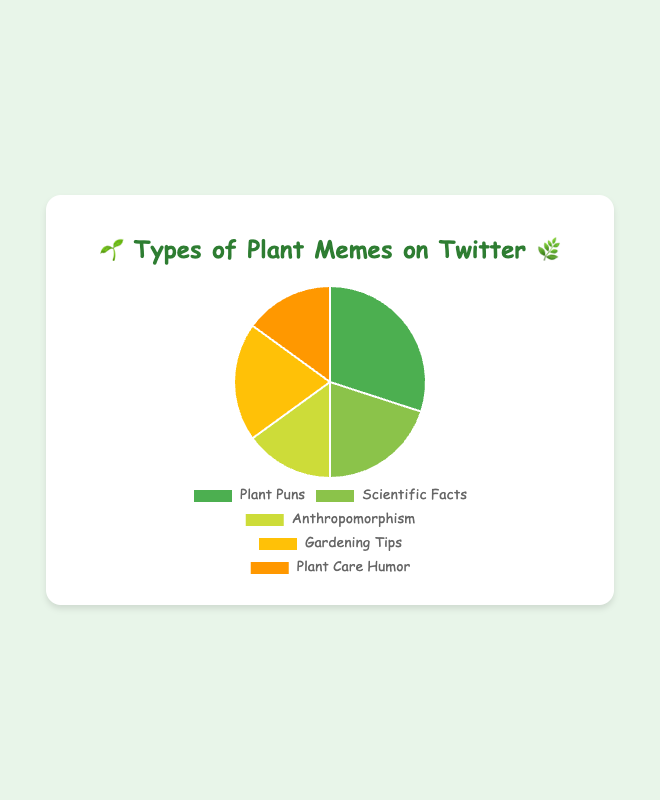What is the percentage of plant memes that are scientific facts? The segment labeled "Scientific Facts" in the pie chart represents the portion of plant memes that are scientific facts. Refer to the figure to find this portion.
Answer: 20% Which type of plant meme has the highest percentage? Look for the largest segment in the pie chart. The label and corresponding percentage indicate the type with the highest value.
Answer: Plant Puns What is the combined percentage of "Gardening Tips" and "Plant Care Humor"? Find the percentages for "Gardening Tips" and "Plant Care Humor". Add these percentages together to get the total. The corresponding segments in the pie chart will help identify these values. Calculation: 20% (Gardening Tips) + 15% (Plant Care Humor) = 35%
Answer: 35% Are there any types of plant memes that have an equal percentage? Compare the percentages of the different types of memes. Check if any two or more types have the same percentage. Identify the segments that have equal sizes and the same percentage labels.
Answer: Yes, there are two types, "Anthropomorphism" and "Plant Care Humor," both at 15% What is the difference in percentage between "Plant Puns" and "Anthropomorphism"? Identify the segments for "Plant Puns" and "Anthropomorphism" and find their respective percentages. Calculate the difference between these percentages. Calculation: 30% (Plant Puns) - 15% (Anthropomorphism) = 15%
Answer: 15% Which two types of memes together make up 50% of the total? Look for combinations of two different meme types whose percentages add up to 50%. Verify this by adding their percentages. One possible combination from the chart is "Plant Puns" and "Scientific Facts". Calculation: 30% (Plant Puns) + 20% (Scientific Facts) = 50%
Answer: Plant Puns and Scientific Facts What color represents "Gardening Tips" in the pie chart? Identify the segment labeled "Gardening Tips" and note its color in the pie chart.
Answer: Yellow How much greater is the percentage of "Plant Puns" compared to "Scientific Facts"? Identify the percentages for "Plant Puns" and "Scientific Facts" and subtract the latter from the former to find the difference. Calculation: 30% (Plant Puns) - 20% (Scientific Facts) = 10%
Answer: 10% What is the average percentage of all types of plant memes? Add the percentages of all types and divide by the number of types to find the average. For this pie chart, the sum is 30% (Plant Puns) + 20% (Scientific Facts) + 15% (Anthropomorphism) + 20% (Gardening Tips) + 15% (Plant Care Humor) = 100%. Then divide by 5 types. Calculation: 100% / 5 = 20%
Answer: 20% Which segment is smaller: "Anthropomorphism" or "Gardening Tips"? Compare the percentages of "Anthropomorphism" and "Gardening Tips" from the pie chart. The smaller percentage will be the answer.
Answer: Anthropomorphism 